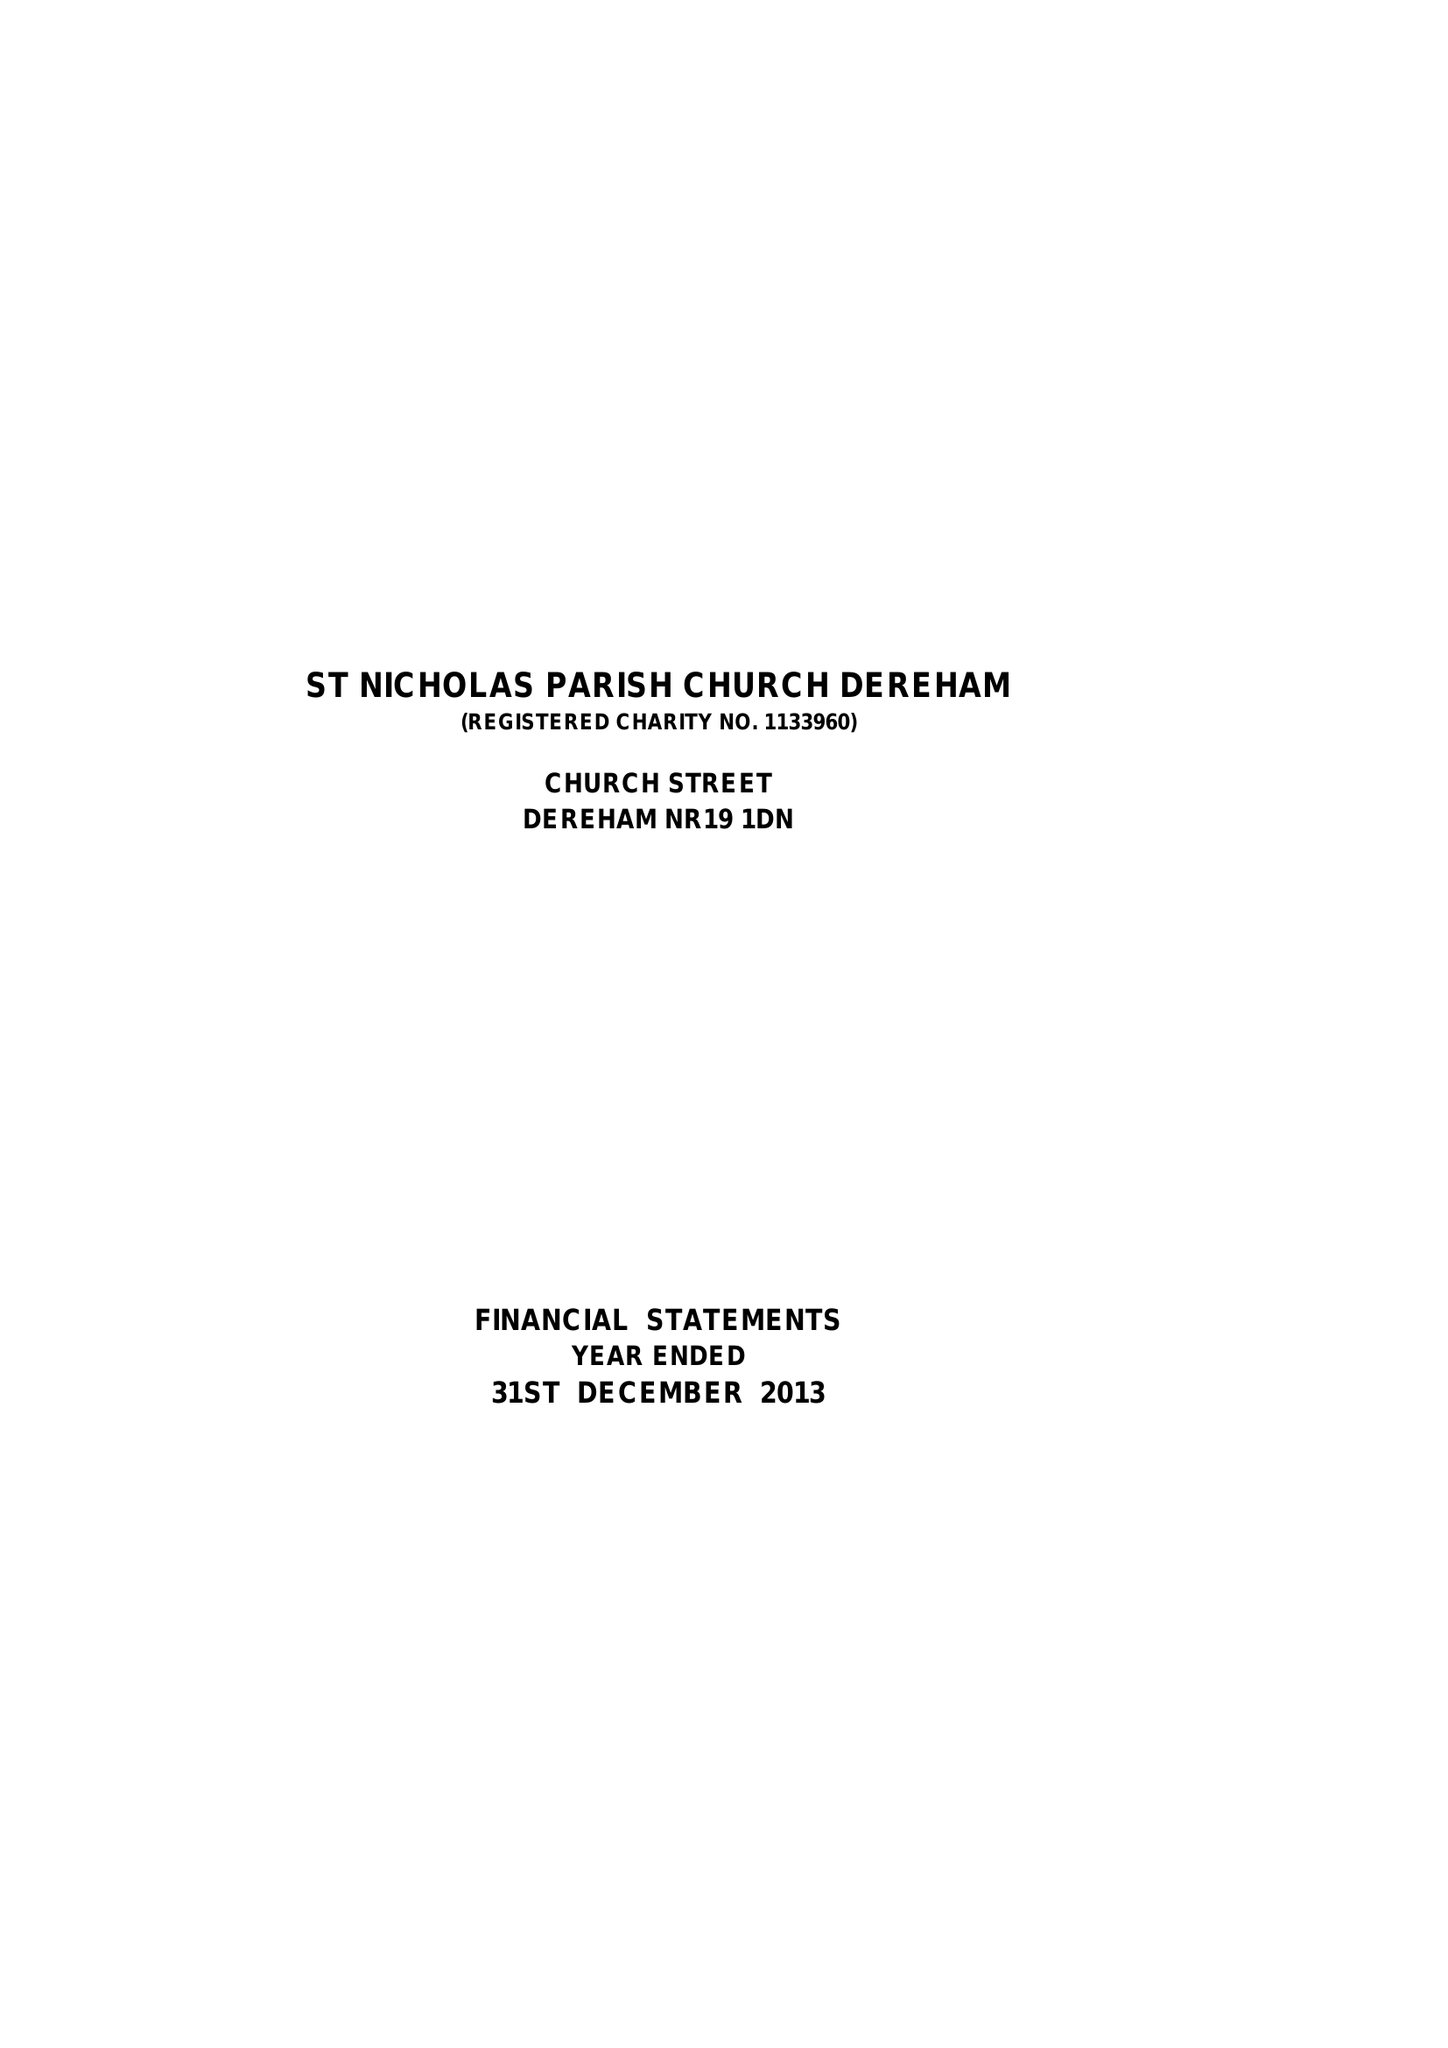What is the value for the spending_annually_in_british_pounds?
Answer the question using a single word or phrase. 197165.00 